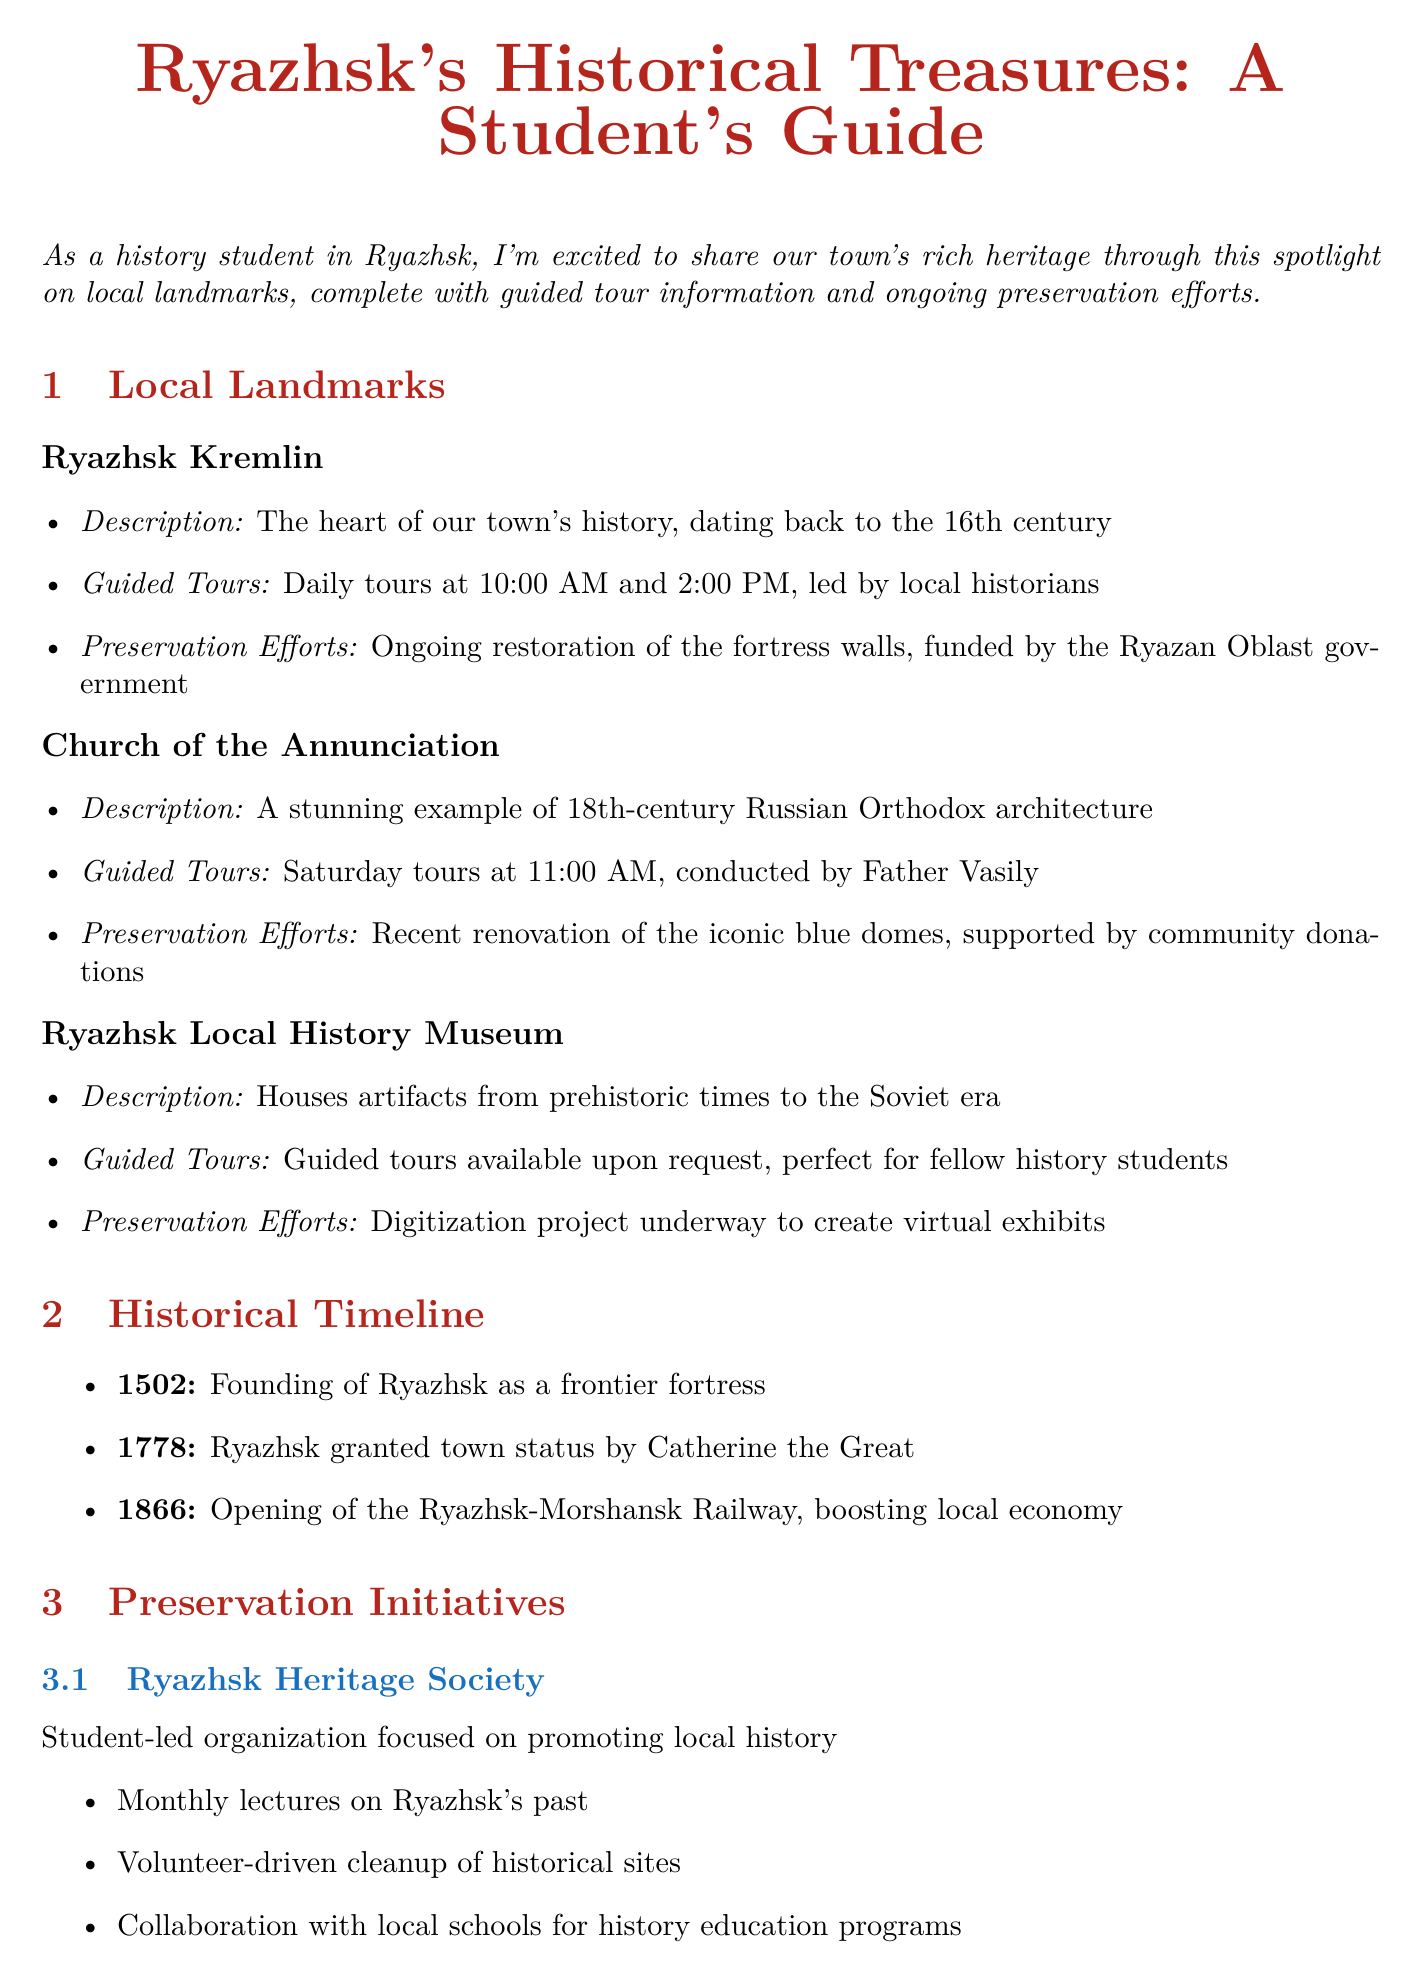What is the title of the newsletter? The title is provided at the beginning of the document and highlights the focus on Ryazhsk's historical landmarks.
Answer: Ryazhsk's Historical Treasures: A Student's Guide What time are the daily tours at the Ryazhsk Kremlin? The document specifies guided tour timings for the Ryazhsk Kremlin.
Answer: 10:00 AM and 2:00 PM Who leads the Saturday tours at the Church of the Annunciation? The document mentions who is responsible for conducting the tours at this landmark.
Answer: Father Vasily What year was Ryazhsk granted town status? This information is found in the historical events timeline presented in the document.
Answer: 1778 What is the name of the community initiative involved in preservation? Mentioned under preservation initiatives, the document describes a specific program engaging local businesses.
Answer: Adopt-a-Landmark Program What type of events are celebrated on Ryazhsk History Day? The document outlines the activities included in this annual celebration.
Answer: Reenactments, traditional crafts, and guided tours What is one activity of the Ryazhsk Heritage Society? The document provides examples of activities undertaken by this student-led organization.
Answer: Monthly lectures on Ryazhsk's past When is the Student Research Symposium scheduled? The document lists upcoming events along with their dates.
Answer: June 10, 2023 What is being restored at the Ryazhsk Kremlin? Preservation efforts for the landmark are detailed in the document.
Answer: Fortress walls 